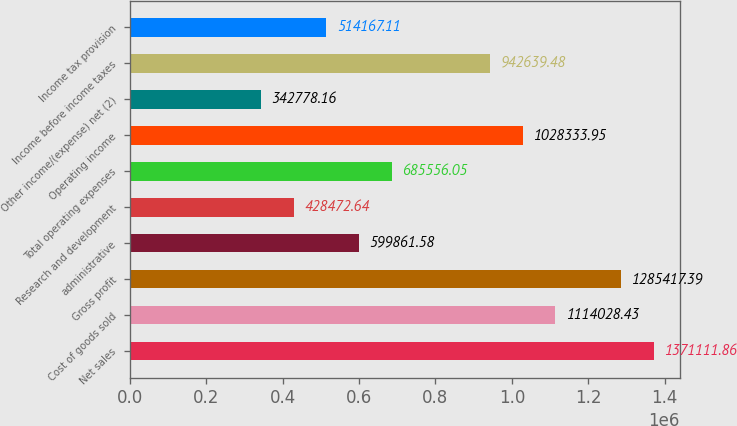Convert chart to OTSL. <chart><loc_0><loc_0><loc_500><loc_500><bar_chart><fcel>Net sales<fcel>Cost of goods sold<fcel>Gross profit<fcel>administrative<fcel>Research and development<fcel>Total operating expenses<fcel>Operating income<fcel>Other income/(expense) net (2)<fcel>Income before income taxes<fcel>Income tax provision<nl><fcel>1.37111e+06<fcel>1.11403e+06<fcel>1.28542e+06<fcel>599862<fcel>428473<fcel>685556<fcel>1.02833e+06<fcel>342778<fcel>942639<fcel>514167<nl></chart> 